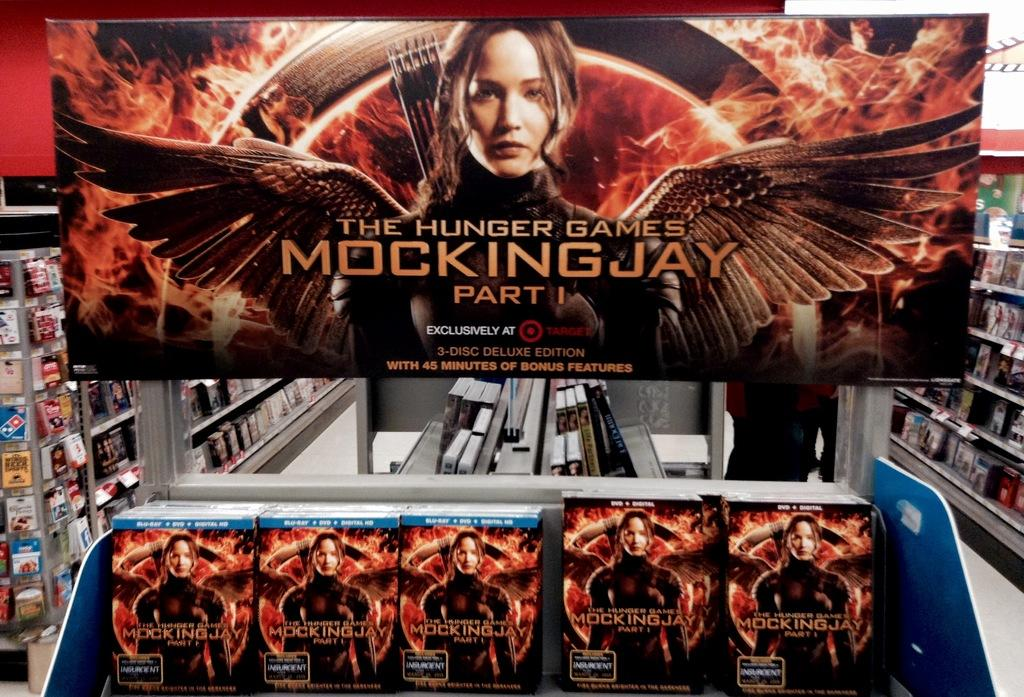<image>
Describe the image concisely. A movie display with DVD's of The Hunger Games Mockingjay according to the billboard above the DVD's 